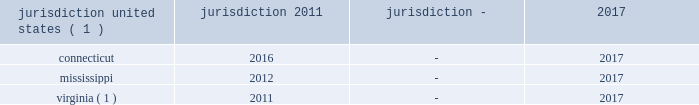And penalties , resulting in a liability of $ 1 million for interest and penalties as of december 31 , 2018 .
In 2017 , there was a net decrease in income tax expense of $ 1 million for interest and penalties , resulting in no material liability for interest and penalties as of december 31 , 2017 .
The 2017 changes in interest and penalties related to statute of limitation expirations .
In 2016 , there was a net decrease in income tax expense of $ 2 million for interest and penalties , resulting in a total liability of $ 1 million for interest and penalties as of december 31 , 2016 .
The 2016 changes in interest and penalties related to reductions in prior year tax positions and settlement with a taxing authority .
The table summarizes the tax years that are either currently under examination or remain open under the applicable statute of limitations and subject to examination by the major tax jurisdictions in which the company operates: .
Virginia ( 1 ) 2011 - 2017 ( 1 ) the 2014 tax year has been closed in these jurisdictions .
Although the company believes it has adequately provided for all uncertain tax positions , amounts asserted by taxing authorities could be greater than the company's accrued position .
Accordingly , additional provisions for federal and state income tax related matters could be recorded in the future as revised estimates are made or the underlying matters are effectively settled or otherwise resolved .
Conversely , the company could settle positions with the tax authorities for amounts lower than have been accrued .
The company believes that it is reasonably possible that during the next 12 months the company's liability for uncertain tax positions may decrease by $ 14 million due to resolution of a federal uncertain tax position .
During 2013 the company entered into the pre-compliance assurance process with the irs for years 2011 and 2012 .
The company is part of the irs compliance assurance process program for the 2014 through 2018 tax years .
Open tax years related to state jurisdictions remain subject to examination .
Deferred income taxes - deferred income taxes reflect the net tax effects of temporary differences between the carrying amounts of assets and liabilities for financial reporting purposes and for income tax purposes .
As described above , deferred tax assets and liabilities are calculated as of the balance sheet date using current tax laws and rates expected to be in effect when the deferred tax items reverse in future periods .
As a result of the reduction in the corporate income tax rate from 35% ( 35 % ) to 21% ( 21 % ) under the tax act , the company revalued its net deferred tax assets as of december 31 , 2017 .
Net deferred tax assets are classified as long-term deferred tax assets in the consolidated statements of financial position. .
What is the liability for interest and penalties as of december 31 , 2017? 
Computations: (1 - 1)
Answer: 0.0. 